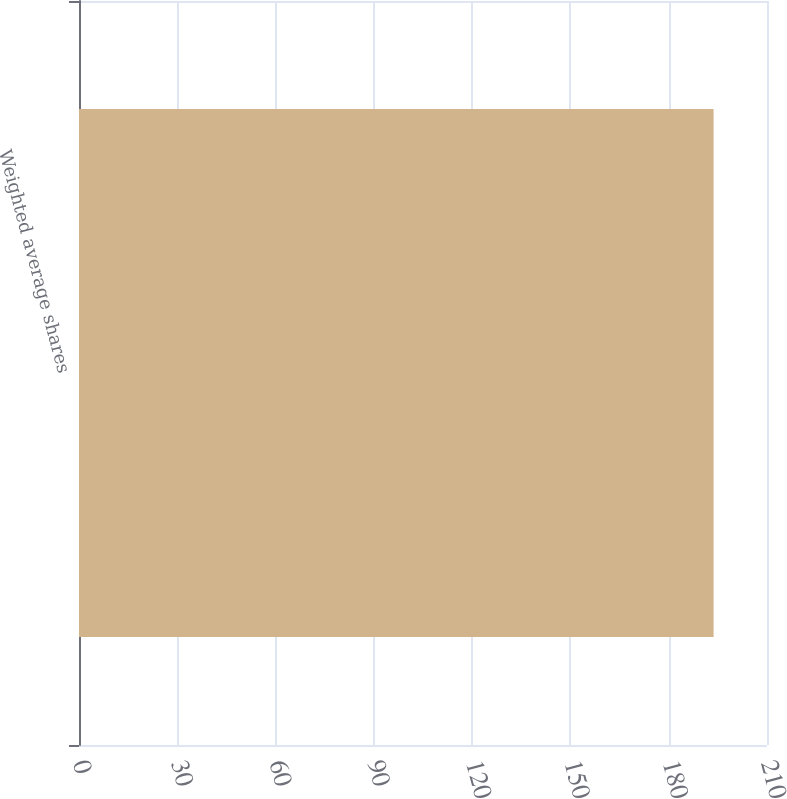Convert chart to OTSL. <chart><loc_0><loc_0><loc_500><loc_500><bar_chart><fcel>Weighted average shares<nl><fcel>193.7<nl></chart> 